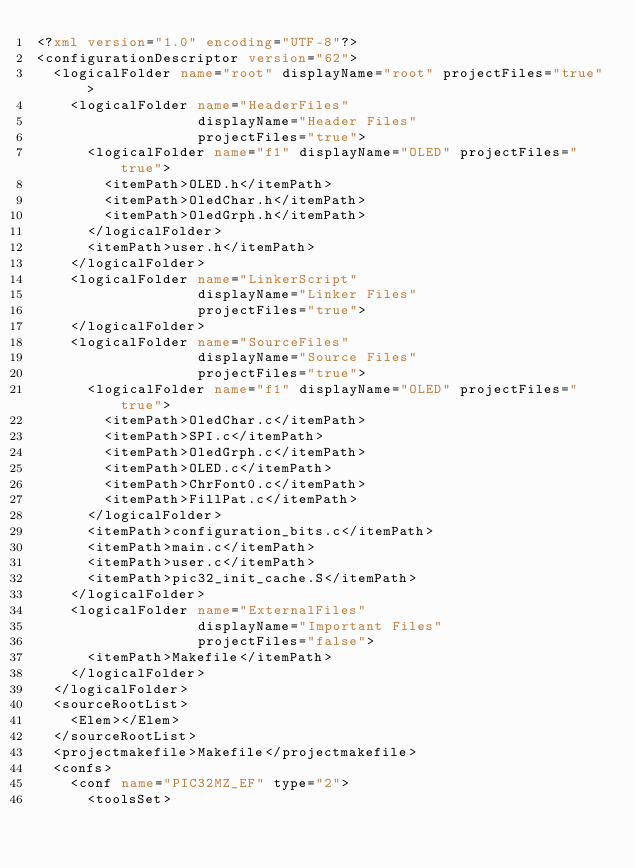Convert code to text. <code><loc_0><loc_0><loc_500><loc_500><_XML_><?xml version="1.0" encoding="UTF-8"?>
<configurationDescriptor version="62">
  <logicalFolder name="root" displayName="root" projectFiles="true">
    <logicalFolder name="HeaderFiles"
                   displayName="Header Files"
                   projectFiles="true">
      <logicalFolder name="f1" displayName="OLED" projectFiles="true">
        <itemPath>OLED.h</itemPath>
        <itemPath>OledChar.h</itemPath>
        <itemPath>OledGrph.h</itemPath>
      </logicalFolder>
      <itemPath>user.h</itemPath>
    </logicalFolder>
    <logicalFolder name="LinkerScript"
                   displayName="Linker Files"
                   projectFiles="true">
    </logicalFolder>
    <logicalFolder name="SourceFiles"
                   displayName="Source Files"
                   projectFiles="true">
      <logicalFolder name="f1" displayName="OLED" projectFiles="true">
        <itemPath>OledChar.c</itemPath>
        <itemPath>SPI.c</itemPath>
        <itemPath>OledGrph.c</itemPath>
        <itemPath>OLED.c</itemPath>
        <itemPath>ChrFont0.c</itemPath>
        <itemPath>FillPat.c</itemPath>
      </logicalFolder>
      <itemPath>configuration_bits.c</itemPath>
      <itemPath>main.c</itemPath>
      <itemPath>user.c</itemPath>
      <itemPath>pic32_init_cache.S</itemPath>
    </logicalFolder>
    <logicalFolder name="ExternalFiles"
                   displayName="Important Files"
                   projectFiles="false">
      <itemPath>Makefile</itemPath>
    </logicalFolder>
  </logicalFolder>
  <sourceRootList>
    <Elem></Elem>
  </sourceRootList>
  <projectmakefile>Makefile</projectmakefile>
  <confs>
    <conf name="PIC32MZ_EF" type="2">
      <toolsSet></code> 